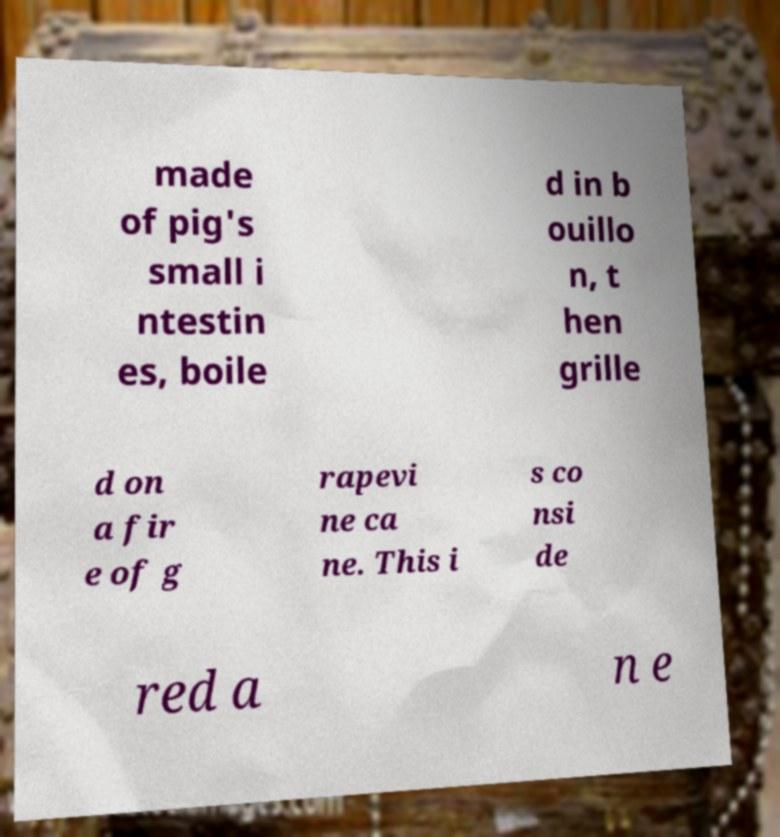Can you read and provide the text displayed in the image?This photo seems to have some interesting text. Can you extract and type it out for me? made of pig's small i ntestin es, boile d in b ouillo n, t hen grille d on a fir e of g rapevi ne ca ne. This i s co nsi de red a n e 